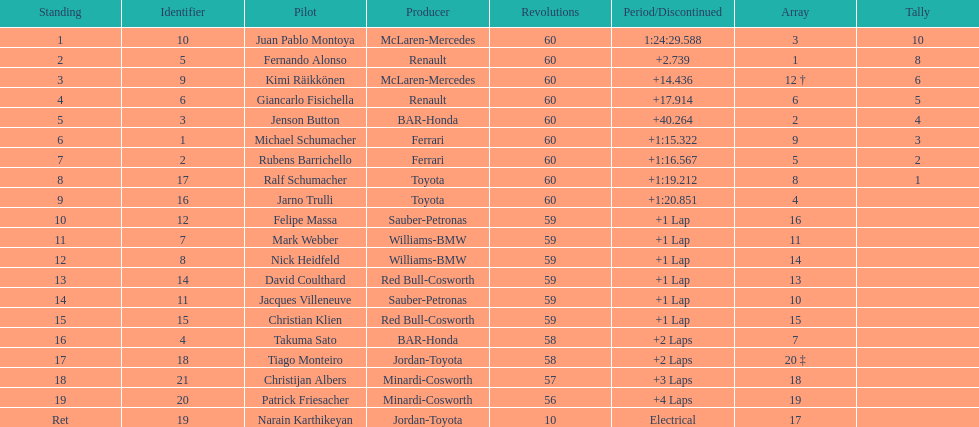Is there a points difference between the 9th position and 19th position on the list? No. 